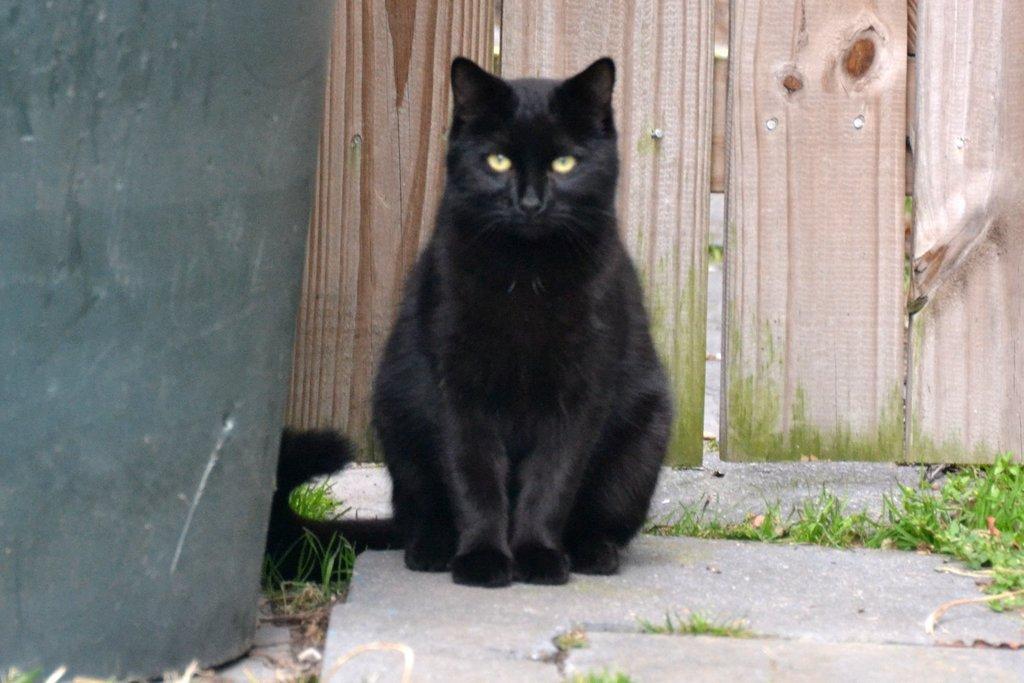How would you summarize this image in a sentence or two? In this image I can see a cat which is black in color is standing on the floor. I can see some grass which is green in color and the wooden surface in the background which is cream and brown in color. To the left side of the image I can see an object. 